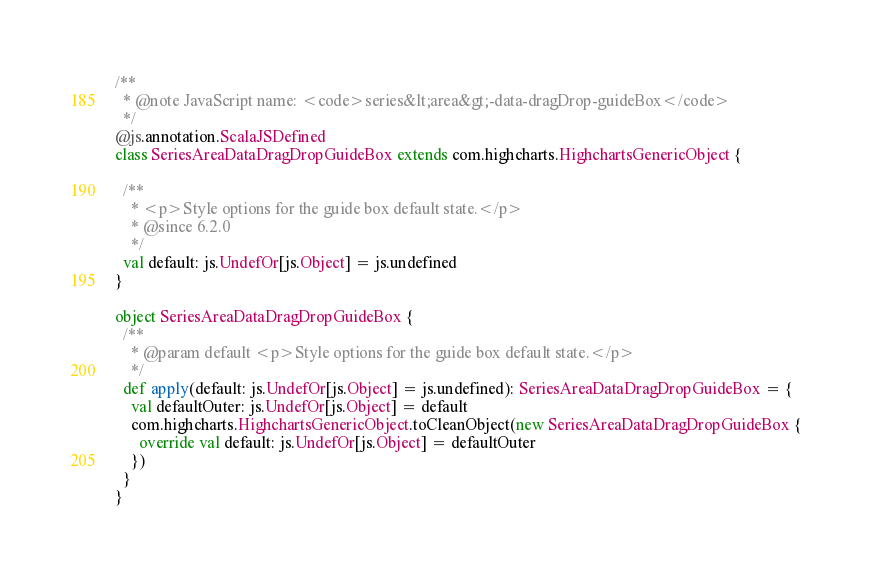<code> <loc_0><loc_0><loc_500><loc_500><_Scala_>/**
  * @note JavaScript name: <code>series&lt;area&gt;-data-dragDrop-guideBox</code>
  */
@js.annotation.ScalaJSDefined
class SeriesAreaDataDragDropGuideBox extends com.highcharts.HighchartsGenericObject {

  /**
    * <p>Style options for the guide box default state.</p>
    * @since 6.2.0
    */
  val default: js.UndefOr[js.Object] = js.undefined
}

object SeriesAreaDataDragDropGuideBox {
  /**
    * @param default <p>Style options for the guide box default state.</p>
    */
  def apply(default: js.UndefOr[js.Object] = js.undefined): SeriesAreaDataDragDropGuideBox = {
    val defaultOuter: js.UndefOr[js.Object] = default
    com.highcharts.HighchartsGenericObject.toCleanObject(new SeriesAreaDataDragDropGuideBox {
      override val default: js.UndefOr[js.Object] = defaultOuter
    })
  }
}
</code> 